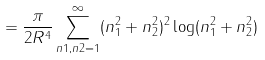Convert formula to latex. <formula><loc_0><loc_0><loc_500><loc_500>= \frac { \pi } { 2 R ^ { 4 } } \sum _ { n 1 , n 2 = 1 } ^ { \infty } ( n _ { 1 } ^ { 2 } + n _ { 2 } ^ { 2 } ) ^ { 2 } \log ( n _ { 1 } ^ { 2 } + n _ { 2 } ^ { 2 } )</formula> 